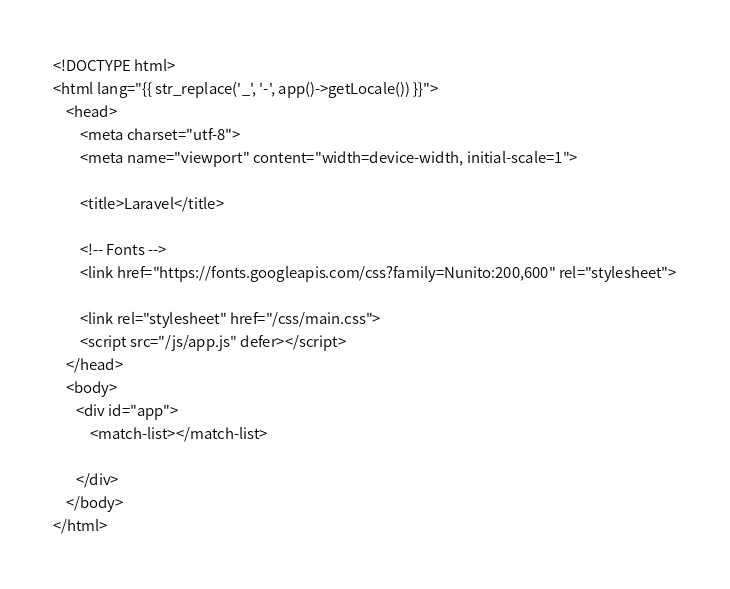Convert code to text. <code><loc_0><loc_0><loc_500><loc_500><_PHP_><!DOCTYPE html>
<html lang="{{ str_replace('_', '-', app()->getLocale()) }}">
    <head>
        <meta charset="utf-8">
        <meta name="viewport" content="width=device-width, initial-scale=1">

        <title>Laravel</title>

        <!-- Fonts -->
        <link href="https://fonts.googleapis.com/css?family=Nunito:200,600" rel="stylesheet">

        <link rel="stylesheet" href="/css/main.css">
        <script src="/js/app.js" defer></script>
    </head>
    <body>
       <div id="app">
           <match-list></match-list>

       </div>
    </body>
</html>
</code> 